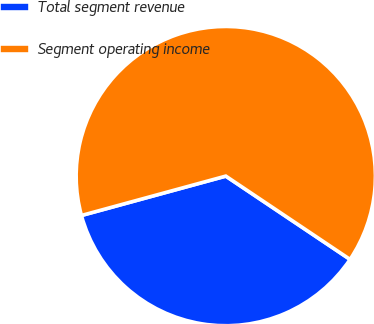Convert chart. <chart><loc_0><loc_0><loc_500><loc_500><pie_chart><fcel>Total segment revenue<fcel>Segment operating income<nl><fcel>36.36%<fcel>63.64%<nl></chart> 